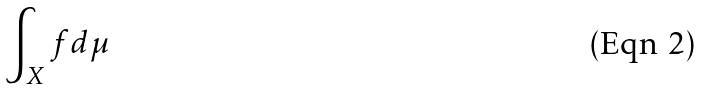Convert formula to latex. <formula><loc_0><loc_0><loc_500><loc_500>\int _ { X } f d \mu</formula> 